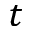Convert formula to latex. <formula><loc_0><loc_0><loc_500><loc_500>t</formula> 